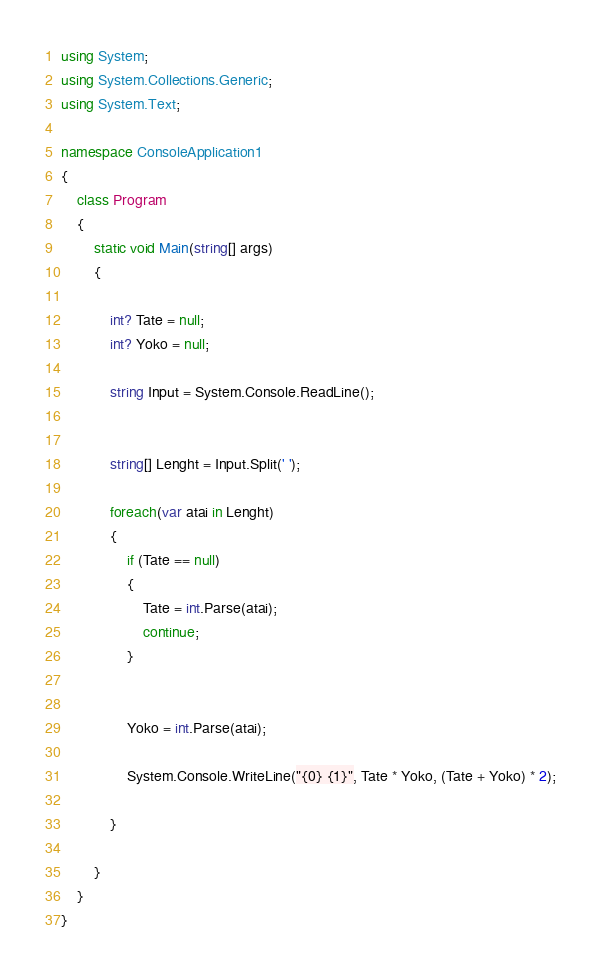<code> <loc_0><loc_0><loc_500><loc_500><_C#_>using System;
using System.Collections.Generic;
using System.Text;

namespace ConsoleApplication1
{
    class Program
    {
        static void Main(string[] args)
        {

            int? Tate = null;
            int? Yoko = null;

            string Input = System.Console.ReadLine();


            string[] Lenght = Input.Split(' '); 

            foreach(var atai in Lenght)
            {
                if (Tate == null)
                {
                    Tate = int.Parse(atai);
                    continue;
                }


                Yoko = int.Parse(atai);

                System.Console.WriteLine("{0} {1}", Tate * Yoko, (Tate + Yoko) * 2);

            }

        }
    }
}</code> 